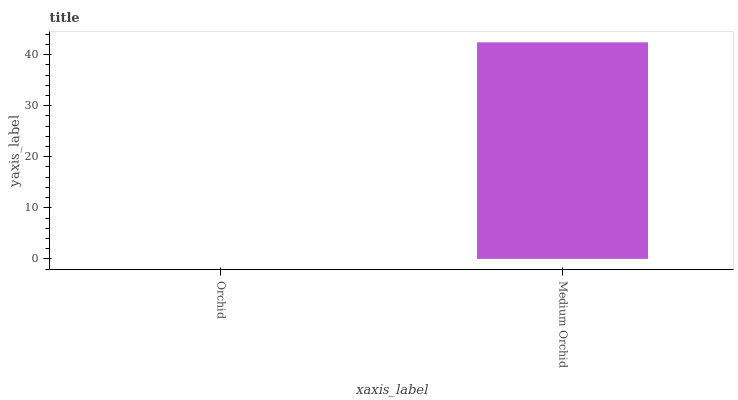Is Orchid the minimum?
Answer yes or no. Yes. Is Medium Orchid the maximum?
Answer yes or no. Yes. Is Medium Orchid the minimum?
Answer yes or no. No. Is Medium Orchid greater than Orchid?
Answer yes or no. Yes. Is Orchid less than Medium Orchid?
Answer yes or no. Yes. Is Orchid greater than Medium Orchid?
Answer yes or no. No. Is Medium Orchid less than Orchid?
Answer yes or no. No. Is Medium Orchid the high median?
Answer yes or no. Yes. Is Orchid the low median?
Answer yes or no. Yes. Is Orchid the high median?
Answer yes or no. No. Is Medium Orchid the low median?
Answer yes or no. No. 